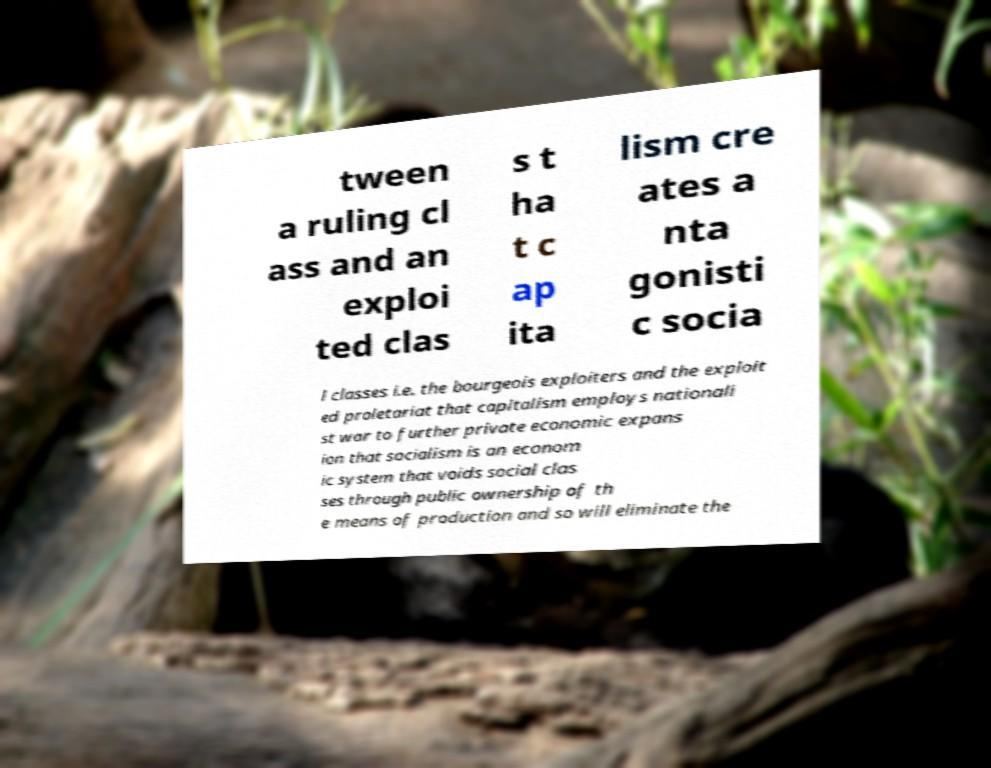Can you read and provide the text displayed in the image?This photo seems to have some interesting text. Can you extract and type it out for me? tween a ruling cl ass and an exploi ted clas s t ha t c ap ita lism cre ates a nta gonisti c socia l classes i.e. the bourgeois exploiters and the exploit ed proletariat that capitalism employs nationali st war to further private economic expans ion that socialism is an econom ic system that voids social clas ses through public ownership of th e means of production and so will eliminate the 